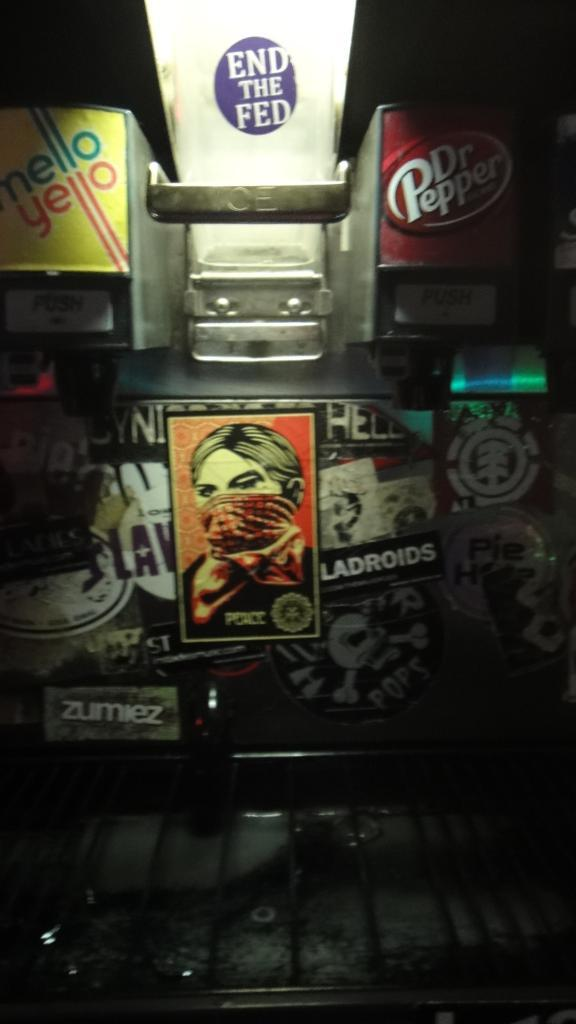<image>
Share a concise interpretation of the image provided. A drink dispenser with Mello Yello and Dr Pepper displayed as well as an "end the fed" sticker on top of it. 